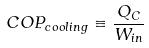<formula> <loc_0><loc_0><loc_500><loc_500>C O P _ { c o o l i n g } \equiv \frac { Q _ { C } } { W _ { i n } }</formula> 